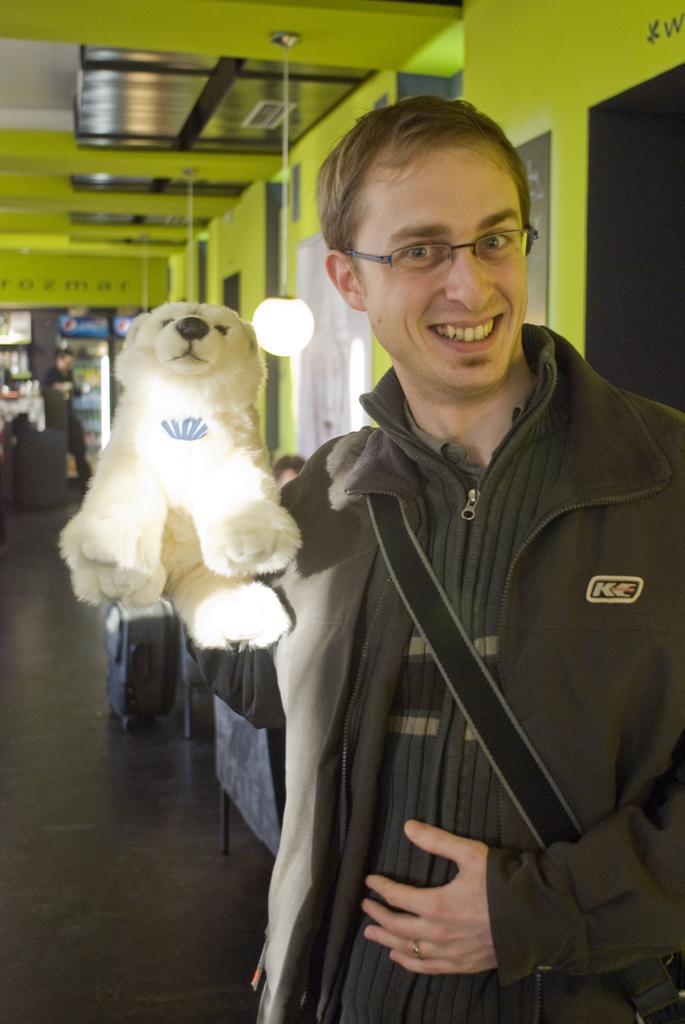How would you summarize this image in a sentence or two? Here I can see a man wearing a jacket, holding a teddy bear in the hand, smiling and giving pose for the picture. At the back of this man there is a wall. On the left side, I can see a luggage bag on the floor. In the background, I can see a refrigerator, in front of this a person is standing. 